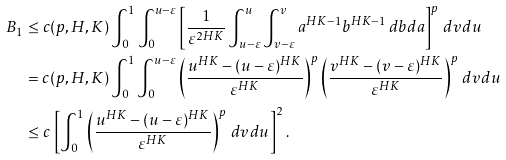<formula> <loc_0><loc_0><loc_500><loc_500>B _ { 1 } & \leq c ( p , H , K ) \int _ { 0 } ^ { 1 } \int _ { 0 } ^ { u - \varepsilon } \left [ \frac { 1 } { \varepsilon ^ { 2 H K } } \int _ { u - \varepsilon } ^ { u } \int _ { v - \varepsilon } ^ { v } a ^ { H K - 1 } b ^ { H K - 1 } \, d b d a \right ] ^ { p } \, d v d u \\ & = c ( p , H , K ) \int _ { 0 } ^ { 1 } \int _ { 0 } ^ { u - \varepsilon } \left ( \frac { u ^ { H K } - ( u - \varepsilon ) ^ { H K } } { \varepsilon ^ { H K } } \right ) ^ { p } \left ( \frac { v ^ { H K } - ( v - \varepsilon ) ^ { H K } } { \varepsilon ^ { H K } } \right ) ^ { p } \, d v d u \\ & \leq c \, \left [ \int _ { 0 } ^ { 1 } \left ( \frac { u ^ { H K } - ( u - \varepsilon ) ^ { H K } } { \varepsilon ^ { H K } } \right ) ^ { p } \, d v d u \right ] ^ { 2 } .</formula> 